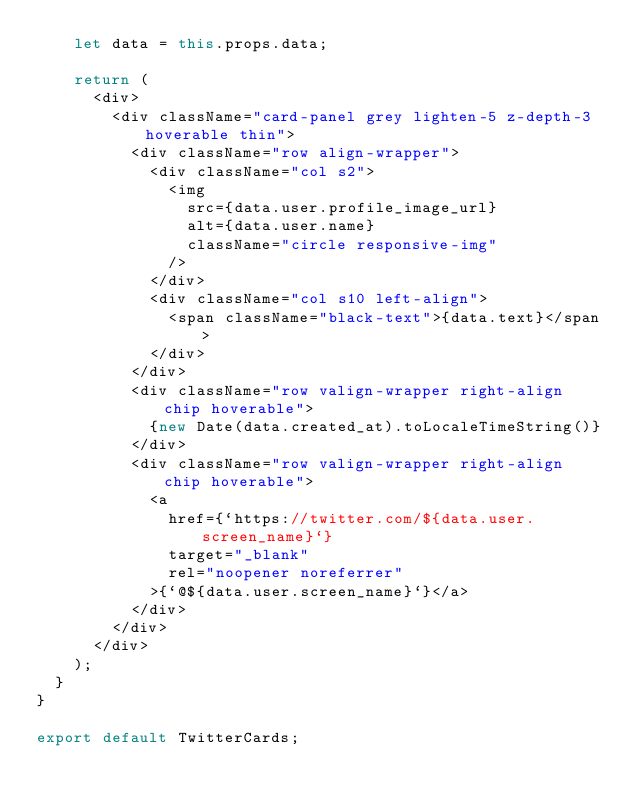<code> <loc_0><loc_0><loc_500><loc_500><_JavaScript_>    let data = this.props.data;

    return (
      <div>
        <div className="card-panel grey lighten-5 z-depth-3 hoverable thin">
          <div className="row align-wrapper">
            <div className="col s2">
              <img
                src={data.user.profile_image_url}
                alt={data.user.name}
                className="circle responsive-img"
              />
            </div>
            <div className="col s10 left-align">
              <span className="black-text">{data.text}</span>
            </div>
          </div>
          <div className="row valign-wrapper right-align chip hoverable">
            {new Date(data.created_at).toLocaleTimeString()}
          </div>
          <div className="row valign-wrapper right-align chip hoverable">
            <a
              href={`https://twitter.com/${data.user.screen_name}`}
              target="_blank"
              rel="noopener noreferrer"
            >{`@${data.user.screen_name}`}</a>
          </div>
        </div>
      </div>
    );
  }
}

export default TwitterCards;
</code> 